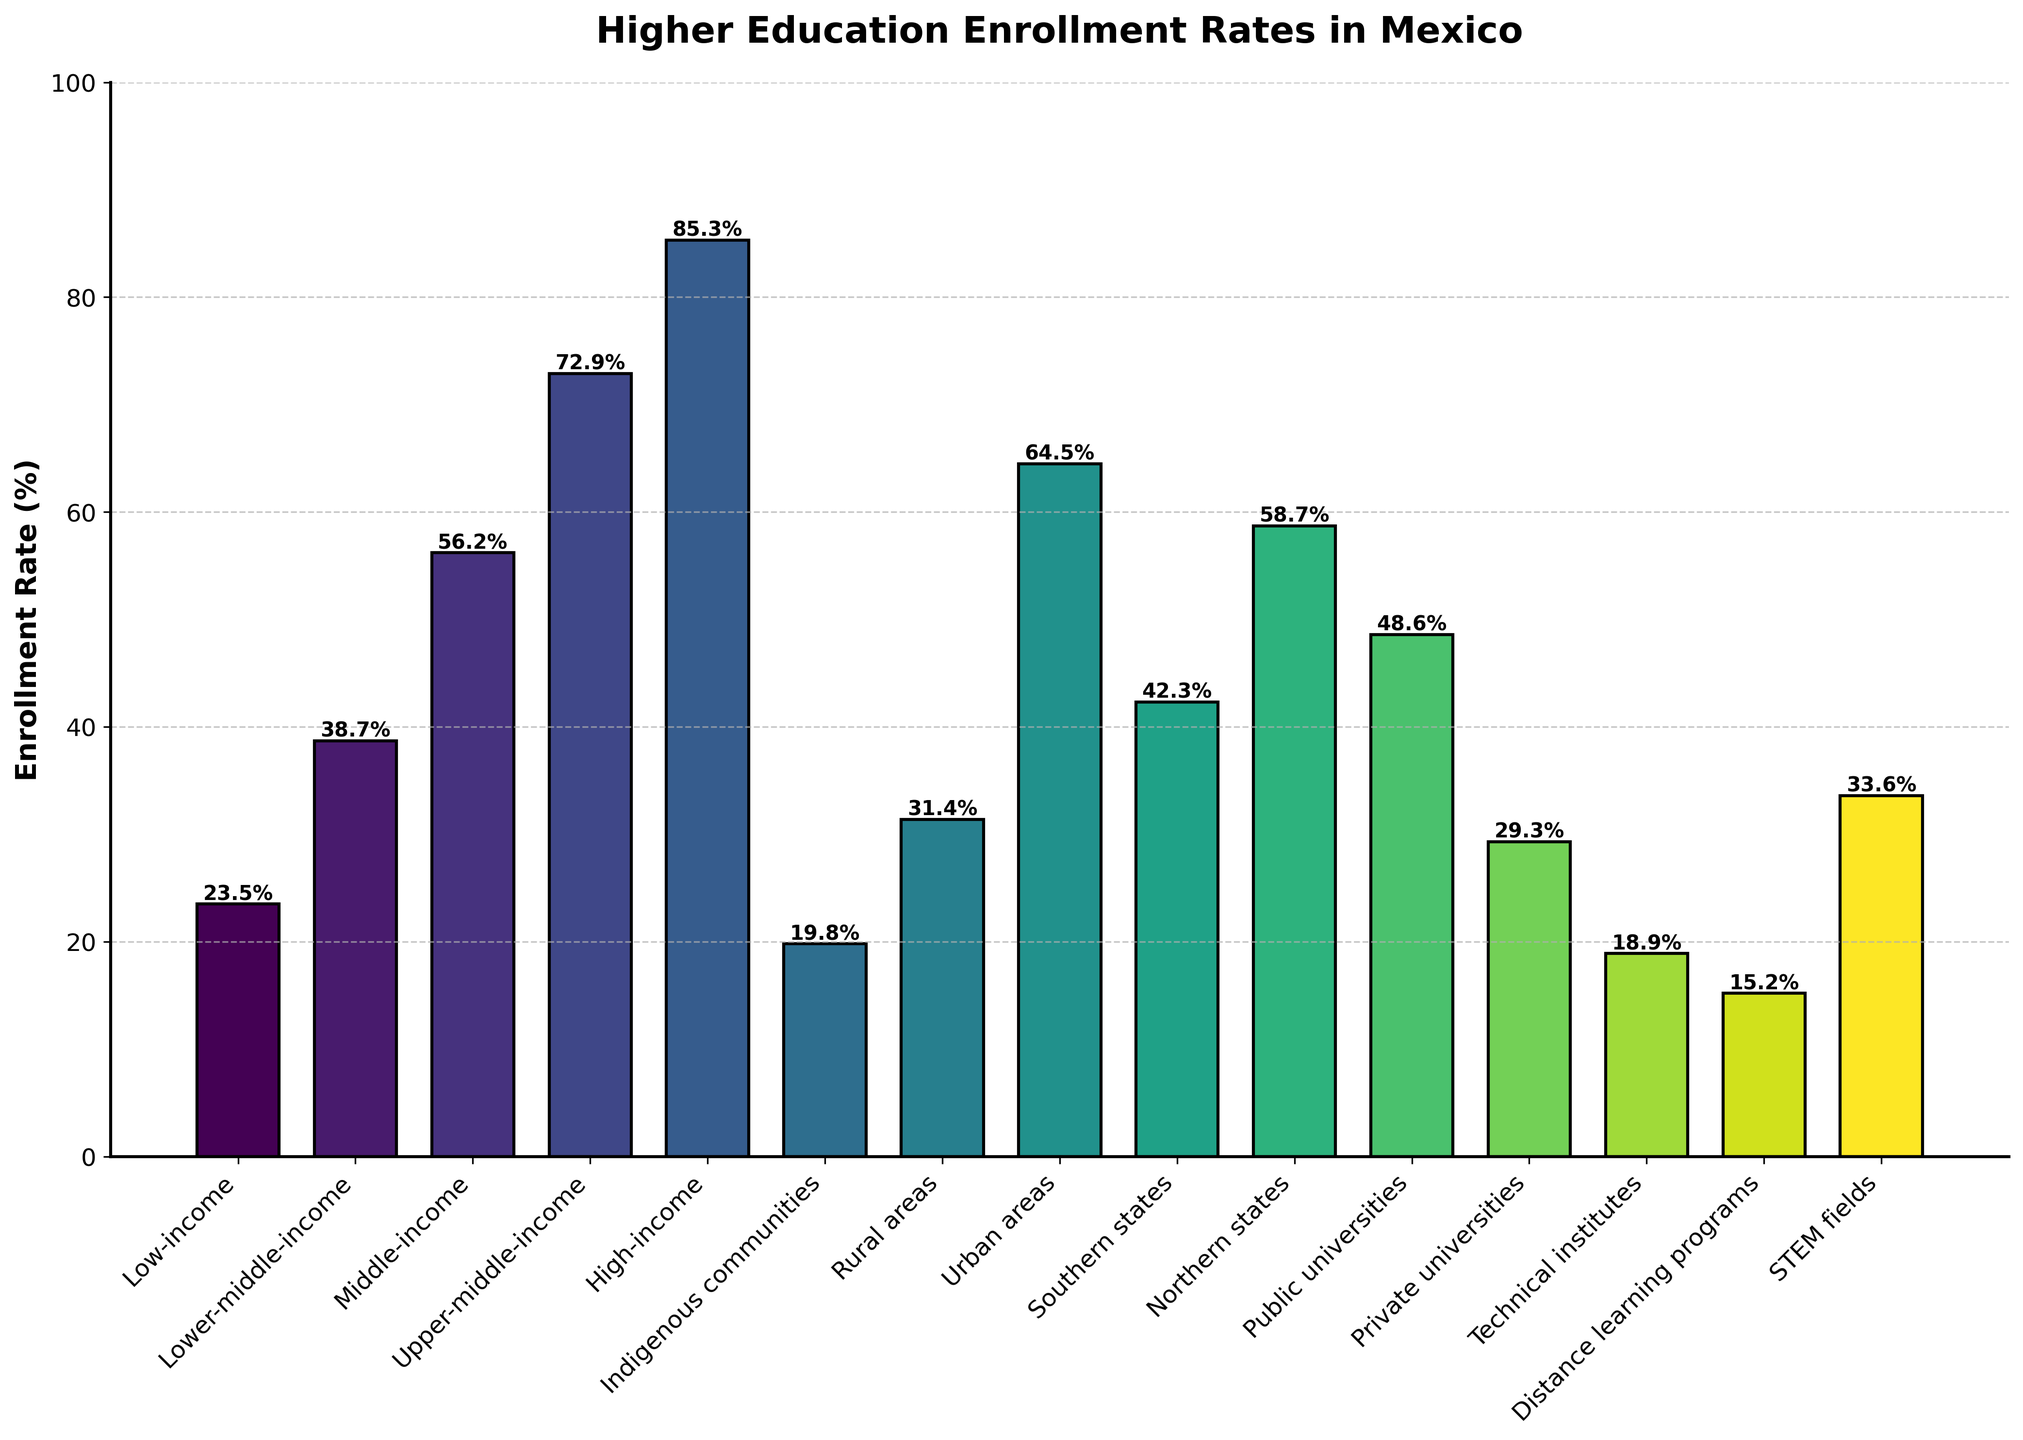Which group has the highest enrollment rate? The highest bar in the chart represents the group with the highest enrollment rate. From the bars, it is the 'High-income' group.
Answer: High-income Which group has the lowest enrollment rate? The lowest bar in the chart represents the group with the lowest enrollment rate. From the bars, it is the 'Distance learning programs' group.
Answer: Distance learning programs What is the difference in enrollment rates between urban areas and rural areas? Identify the bars for 'Urban areas' and 'Rural areas' and note their heights (64.5% for urban and 31.4% for rural). Subtract the rural rate from the urban rate: 64.5% - 31.4% = 33.1%.
Answer: 33.1% Which has a higher enrollment rate: middle-income or lower-middle-income groups? Compare the heights of the bars for 'Middle-income' and 'Lower-middle-income'. Middle-income has a rate of 56.2% and Lower-middle-income has 38.7%.
Answer: Middle-income Are enrollment rates in Public universities higher or lower than in Private universities? Compare the heights of the bars for 'Public universities' (48.6%) and 'Private universities' (29.3%). Public universities have higher enrollment rates.
Answer: Higher What is the average enrollment rate across all socioeconomic groups (Low-income, Lower-middle-income, Middle-income, Upper-middle-income, High-income, Indigenous communities)? Sum the rates of these six groups and divide by the number of groups: (23.5% + 38.7% + 56.2% + 72.9% + 85.3% + 19.8%) / 6 = 296.4% / 6 = 49.4%.
Answer: 49.4% Which group has a closer enrollment rate to Southern states: Indigenous communities or Rural areas? Compare the enrollment rate of 'Southern states' (42.3%) with 'Indigenous communities' (19.8%) and 'Rural areas' (31.4%); 42.3% is closer to 31.4% than to 19.8%.
Answer: Rural areas Which groups have an enrollment rate above 50%? Identify the bars that extend above the 50% mark: 'Middle-income' (56.2%), 'Upper-middle-income' (72.9%), 'High-income' (85.3%), and 'Urban areas' (64.5%).
Answer: Middle-income, Upper-middle-income, High-income, Urban areas What's the enrollment rate difference between Public universities and Technical institutes? Identify the bars for 'Public universities' (48.6%) and 'Technical institutes' (18.9%). Subtract the Technical institutes rate from the Public universities rate: 48.6% - 18.9% = 29.7%.
Answer: 29.7% 